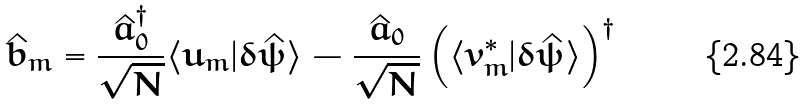<formula> <loc_0><loc_0><loc_500><loc_500>\hat { b } _ { m } = \frac { \hat { a } _ { 0 } ^ { \dagger } } { \sqrt { N } } \langle u _ { m } | \delta \hat { \psi } \rangle - \frac { \hat { a } _ { 0 } } { \sqrt { N } } \left ( \langle v _ { m } ^ { * } | \delta \hat { \psi } \rangle \right ) ^ { \dagger }</formula> 